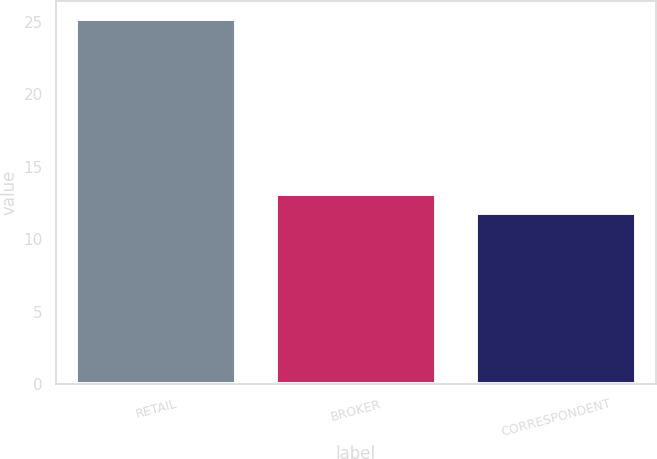Convert chart. <chart><loc_0><loc_0><loc_500><loc_500><bar_chart><fcel>RETAIL<fcel>BROKER<fcel>CORRESPONDENT<nl><fcel>25.2<fcel>13.14<fcel>11.8<nl></chart> 